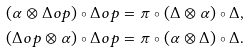<formula> <loc_0><loc_0><loc_500><loc_500>( \alpha \otimes \Delta o p ) \circ \Delta o p & = \pi \circ ( \Delta \otimes \alpha ) \circ \Delta , \\ ( \Delta o p \otimes \alpha ) \circ \Delta o p & = \pi \circ ( \alpha \otimes \Delta ) \circ \Delta .</formula> 